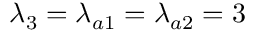Convert formula to latex. <formula><loc_0><loc_0><loc_500><loc_500>\lambda _ { 3 } = \lambda _ { a 1 } = \lambda _ { a 2 } = 3</formula> 